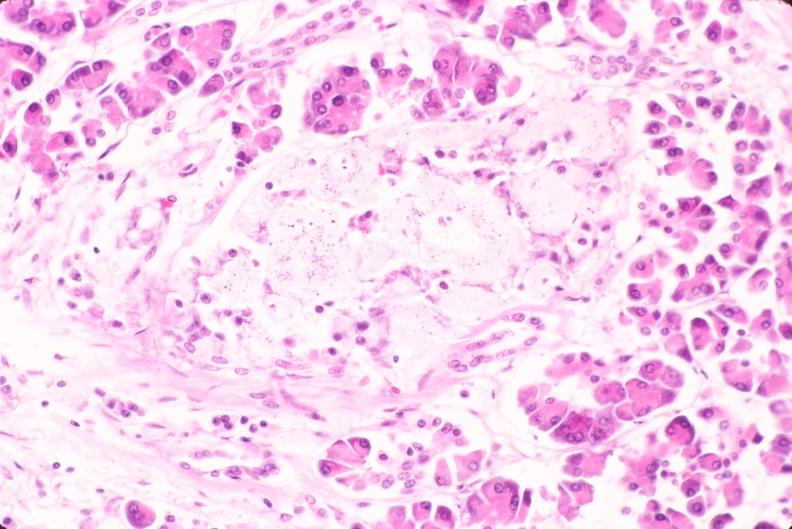does omentum show pancreas, islet hyalinization, diabetes mellitus?
Answer the question using a single word or phrase. No 